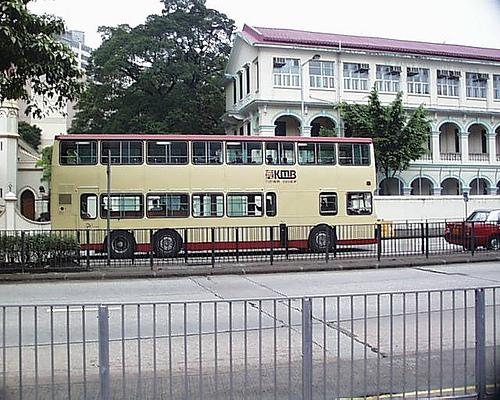Question: what is in the background?
Choices:
A. A tree.
B. A building.
C. A river.
D. A statue.
Answer with the letter. Answer: B Question: what colors are the bus?
Choices:
A. Yellow.
B. Blue.
C. Black.
D. Tan and red.
Answer with the letter. Answer: D Question: what vehicles are shown?
Choices:
A. A train and a truck.
B. A bus and a car.
C. A motorcycle and a van.
D. A bicycle and a scooter.
Answer with the letter. Answer: B Question: what color is the car?
Choices:
A. Black.
B. Red.
C. Silver.
D. Blue.
Answer with the letter. Answer: B Question: when was this photo taken?
Choices:
A. In the daytime.
B. At night.
C. During the game.
D. A week ago.
Answer with the letter. Answer: A Question: what is in the front?
Choices:
A. A person.
B. Me.
C. The car.
D. You.
Answer with the letter. Answer: C 